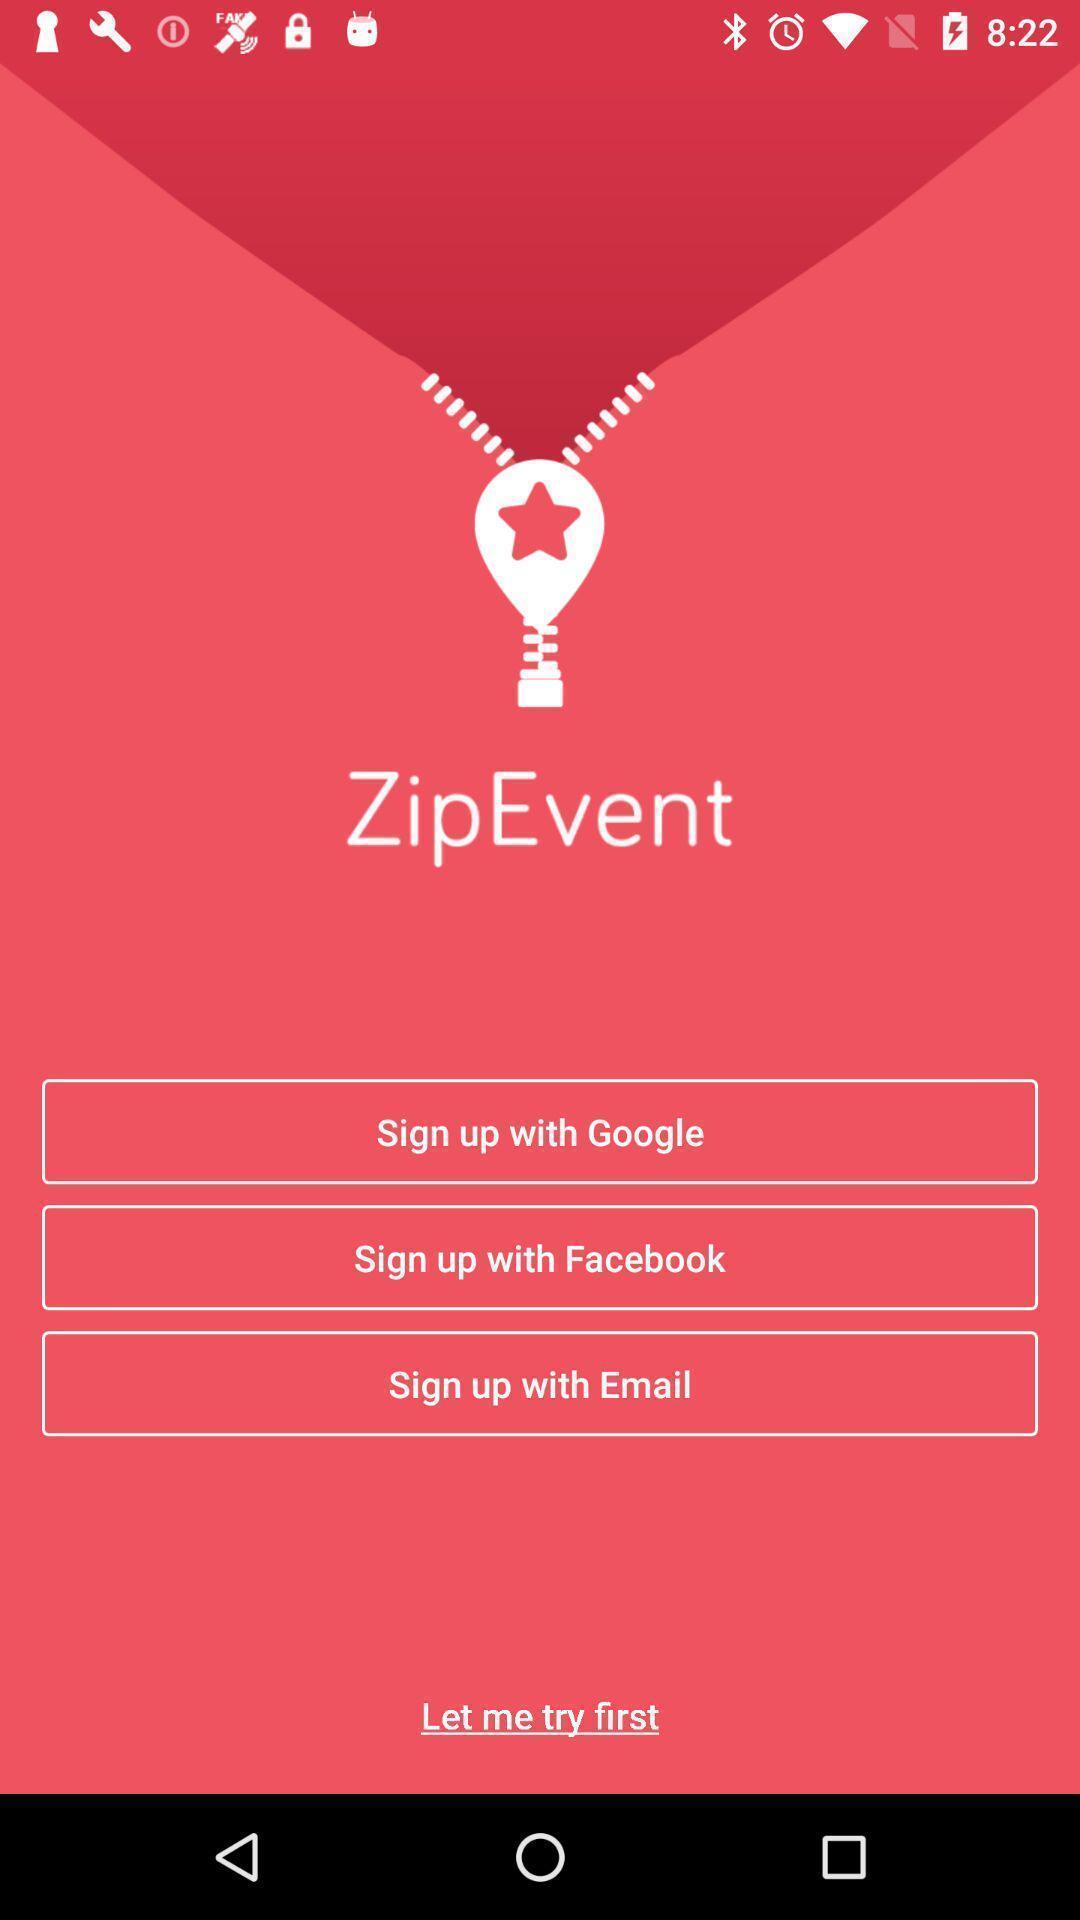Describe the content in this image. Sign up page for an event application. 